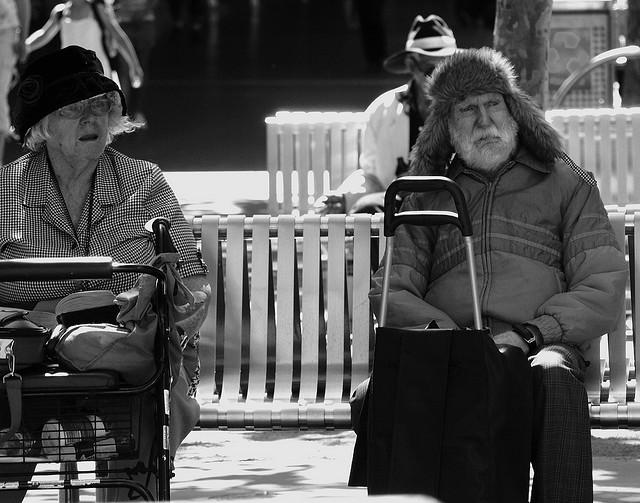How many people are wearing hats?
Answer briefly. 3. Is the man wearing a watch?
Keep it brief. Yes. Is the image in black and white?
Answer briefly. Yes. 